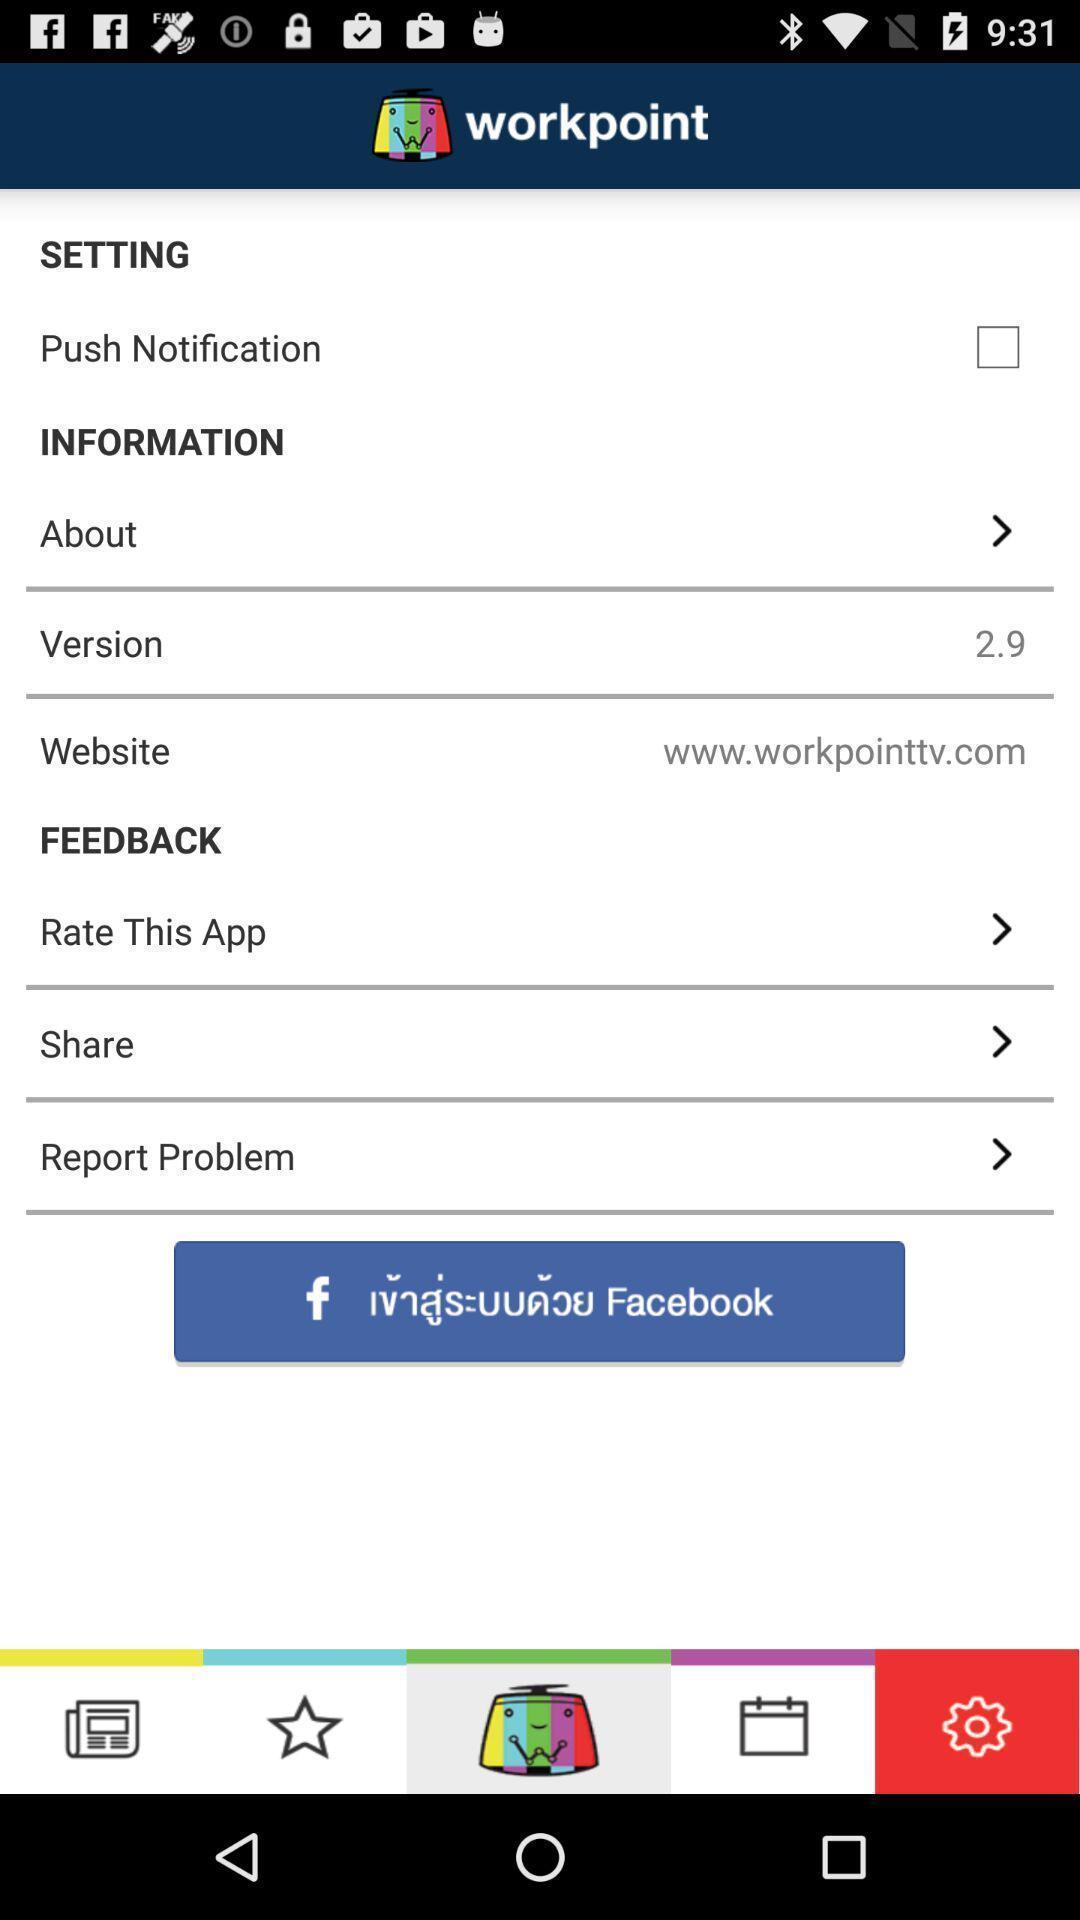Provide a textual representation of this image. Screen showing settings page. 